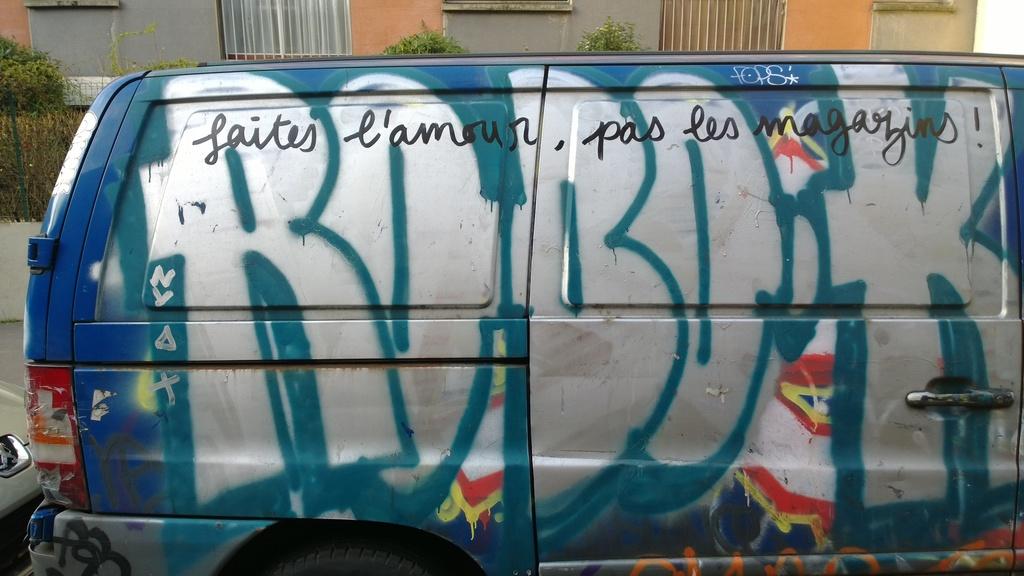Rebok van its travel vechicle?
Offer a very short reply. Not a question. 